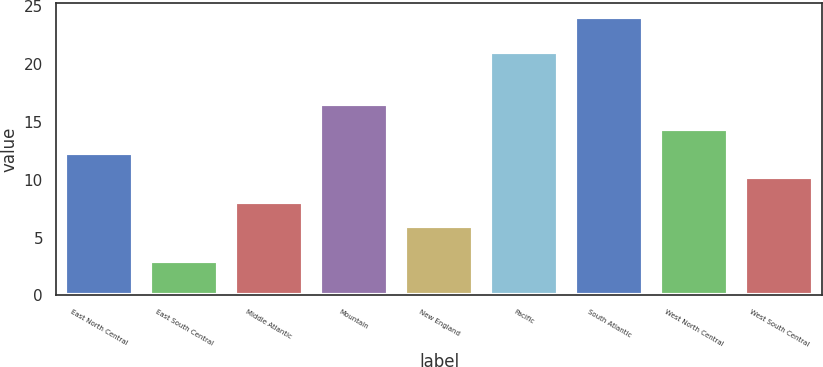<chart> <loc_0><loc_0><loc_500><loc_500><bar_chart><fcel>East North Central<fcel>East South Central<fcel>Middle Atlantic<fcel>Mountain<fcel>New England<fcel>Pacific<fcel>South Atlantic<fcel>West North Central<fcel>West South Central<nl><fcel>12.3<fcel>3<fcel>8.1<fcel>16.5<fcel>6<fcel>21<fcel>24<fcel>14.4<fcel>10.2<nl></chart> 